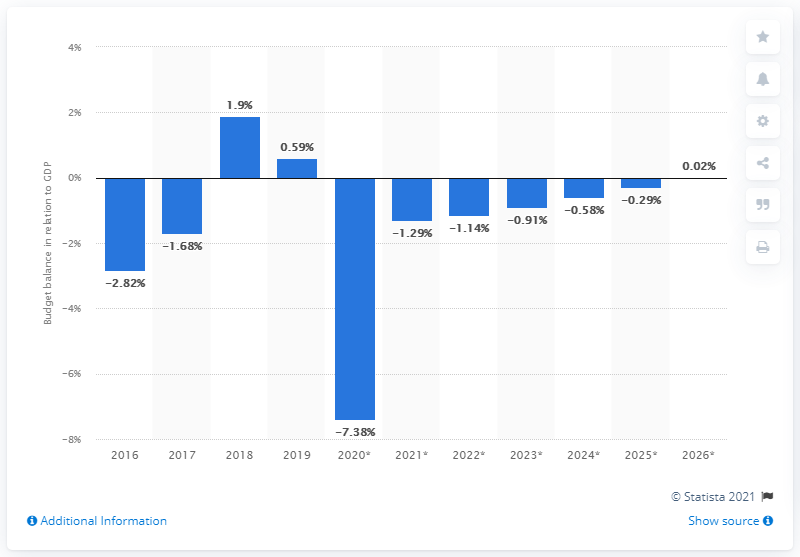Mention a couple of crucial points in this snapshot. In 2019, 0.59% of the country's GDP was surplused. 